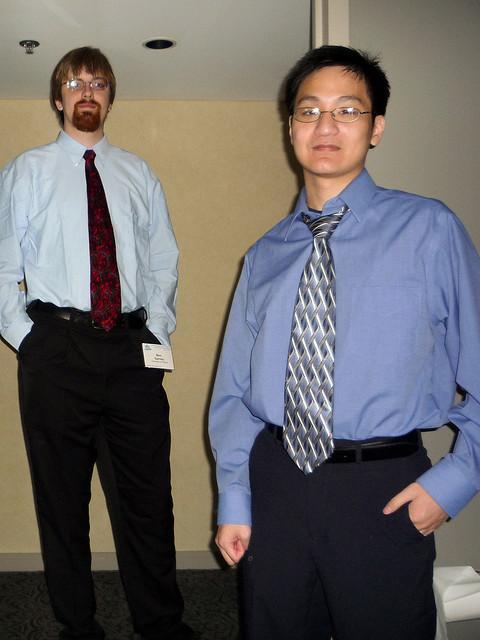How many people are in the photo?
Give a very brief answer. 2. How many people are in photo?
Give a very brief answer. 2. How many ties are there?
Give a very brief answer. 2. How many people can you see?
Give a very brief answer. 2. 